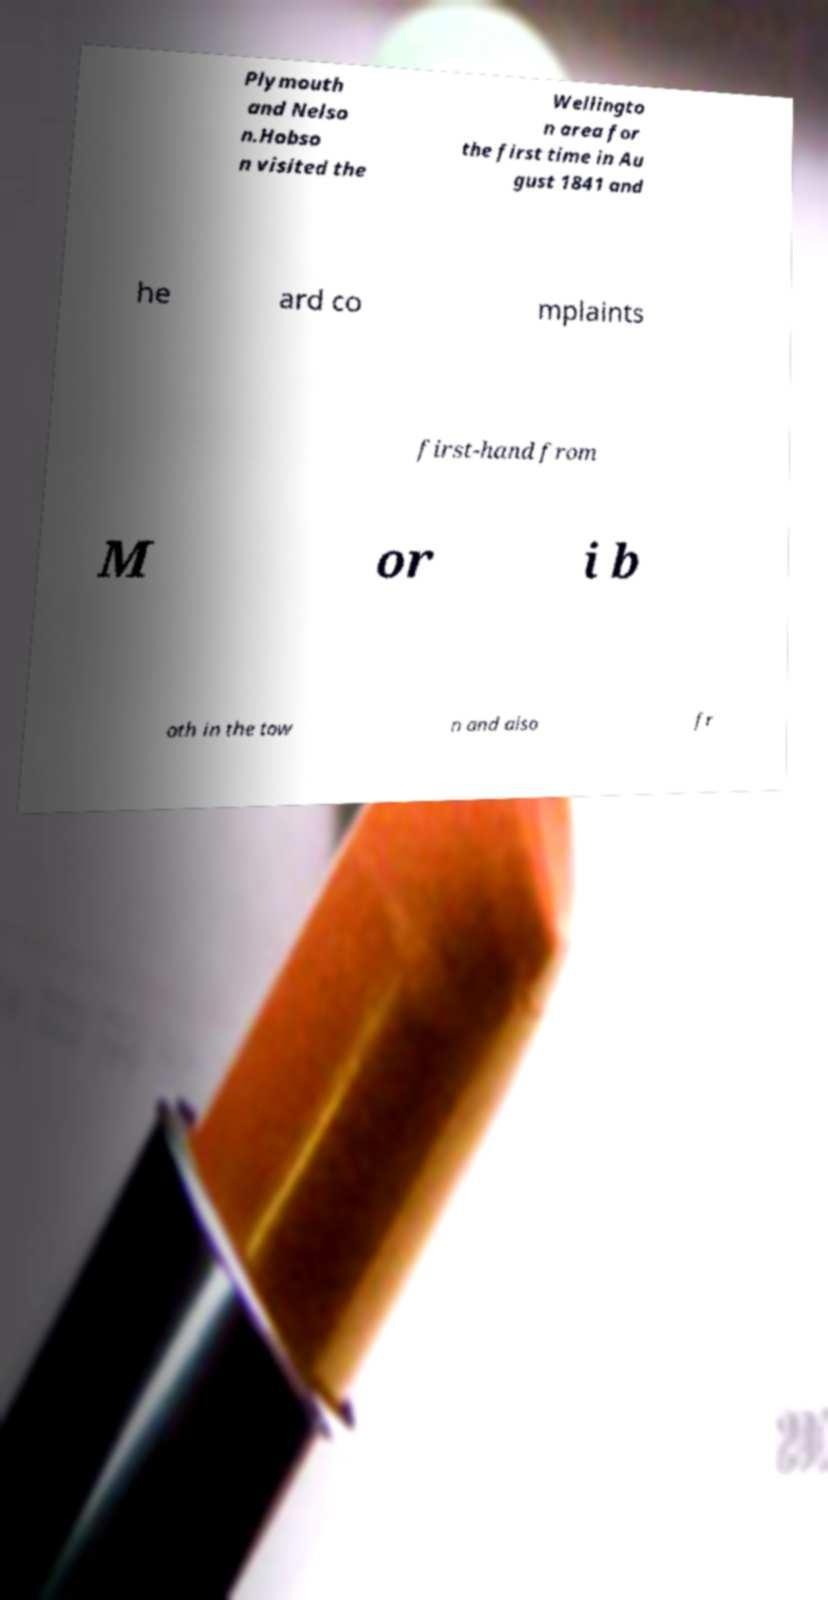Please identify and transcribe the text found in this image. Plymouth and Nelso n.Hobso n visited the Wellingto n area for the first time in Au gust 1841 and he ard co mplaints first-hand from M or i b oth in the tow n and also fr 